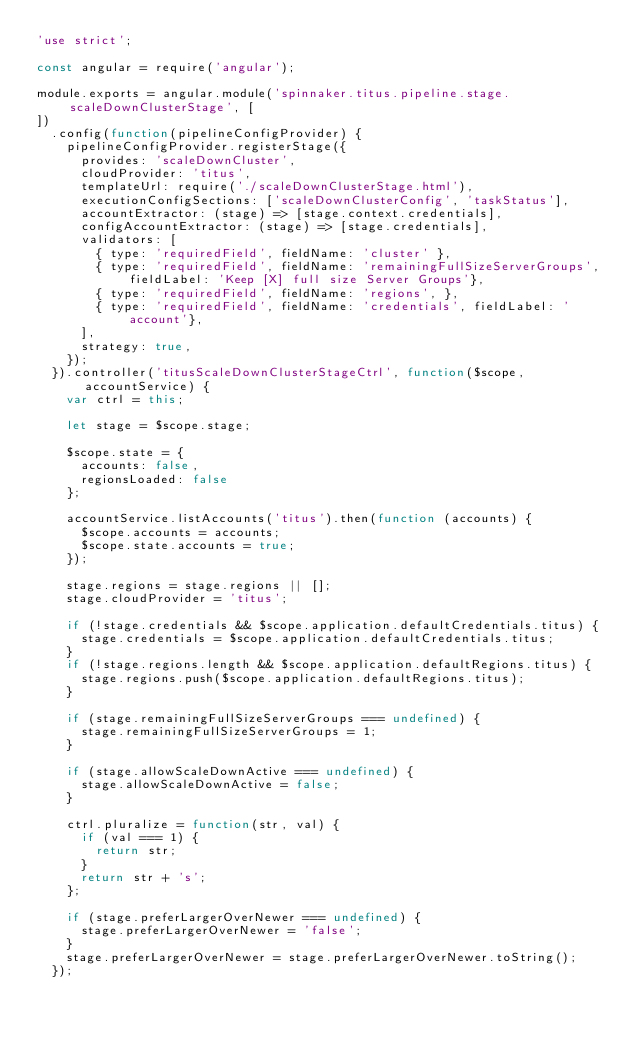<code> <loc_0><loc_0><loc_500><loc_500><_JavaScript_>'use strict';

const angular = require('angular');

module.exports = angular.module('spinnaker.titus.pipeline.stage.scaleDownClusterStage', [
])
  .config(function(pipelineConfigProvider) {
    pipelineConfigProvider.registerStage({
      provides: 'scaleDownCluster',
      cloudProvider: 'titus',
      templateUrl: require('./scaleDownClusterStage.html'),
      executionConfigSections: ['scaleDownClusterConfig', 'taskStatus'],
      accountExtractor: (stage) => [stage.context.credentials],
      configAccountExtractor: (stage) => [stage.credentials],
      validators: [
        { type: 'requiredField', fieldName: 'cluster' },
        { type: 'requiredField', fieldName: 'remainingFullSizeServerGroups', fieldLabel: 'Keep [X] full size Server Groups'},
        { type: 'requiredField', fieldName: 'regions', },
        { type: 'requiredField', fieldName: 'credentials', fieldLabel: 'account'},
      ],
      strategy: true,
    });
  }).controller('titusScaleDownClusterStageCtrl', function($scope, accountService) {
    var ctrl = this;

    let stage = $scope.stage;

    $scope.state = {
      accounts: false,
      regionsLoaded: false
    };

    accountService.listAccounts('titus').then(function (accounts) {
      $scope.accounts = accounts;
      $scope.state.accounts = true;
    });

    stage.regions = stage.regions || [];
    stage.cloudProvider = 'titus';

    if (!stage.credentials && $scope.application.defaultCredentials.titus) {
      stage.credentials = $scope.application.defaultCredentials.titus;
    }
    if (!stage.regions.length && $scope.application.defaultRegions.titus) {
      stage.regions.push($scope.application.defaultRegions.titus);
    }

    if (stage.remainingFullSizeServerGroups === undefined) {
      stage.remainingFullSizeServerGroups = 1;
    }

    if (stage.allowScaleDownActive === undefined) {
      stage.allowScaleDownActive = false;
    }

    ctrl.pluralize = function(str, val) {
      if (val === 1) {
        return str;
      }
      return str + 's';
    };

    if (stage.preferLargerOverNewer === undefined) {
      stage.preferLargerOverNewer = 'false';
    }
    stage.preferLargerOverNewer = stage.preferLargerOverNewer.toString();
  });

</code> 